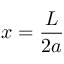<formula> <loc_0><loc_0><loc_500><loc_500>x = \frac { L } { 2 a }</formula> 